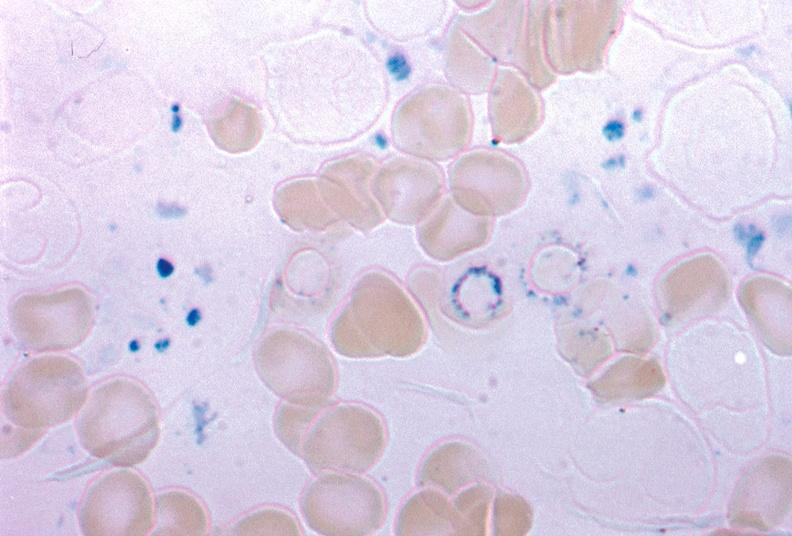what is present?
Answer the question using a single word or phrase. Sideroblasts 